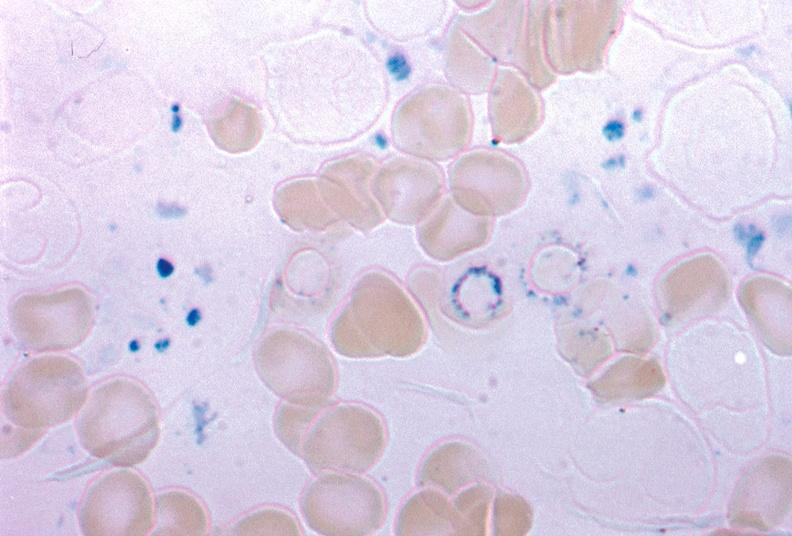what is present?
Answer the question using a single word or phrase. Sideroblasts 